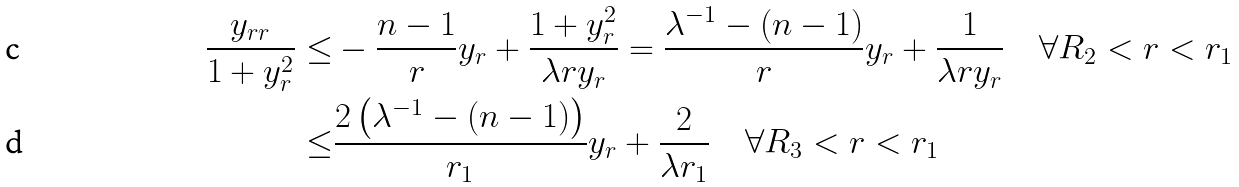<formula> <loc_0><loc_0><loc_500><loc_500>\frac { y _ { r r } } { 1 + y _ { r } ^ { 2 } } \leq & - \frac { n - 1 } { r } y _ { r } + \frac { 1 + y _ { r } ^ { 2 } } { \lambda r y _ { r } } = \frac { \lambda ^ { - 1 } - ( n - 1 ) } { r } y _ { r } + \frac { 1 } { \lambda r y _ { r } } \quad \forall R _ { 2 } < r < r _ { 1 } \\ \leq & \frac { 2 \left ( \lambda ^ { - 1 } - ( n - 1 ) \right ) } { r _ { 1 } } y _ { r } + \frac { 2 } { \lambda r _ { 1 } } \quad \forall R _ { 3 } < r < r _ { 1 }</formula> 